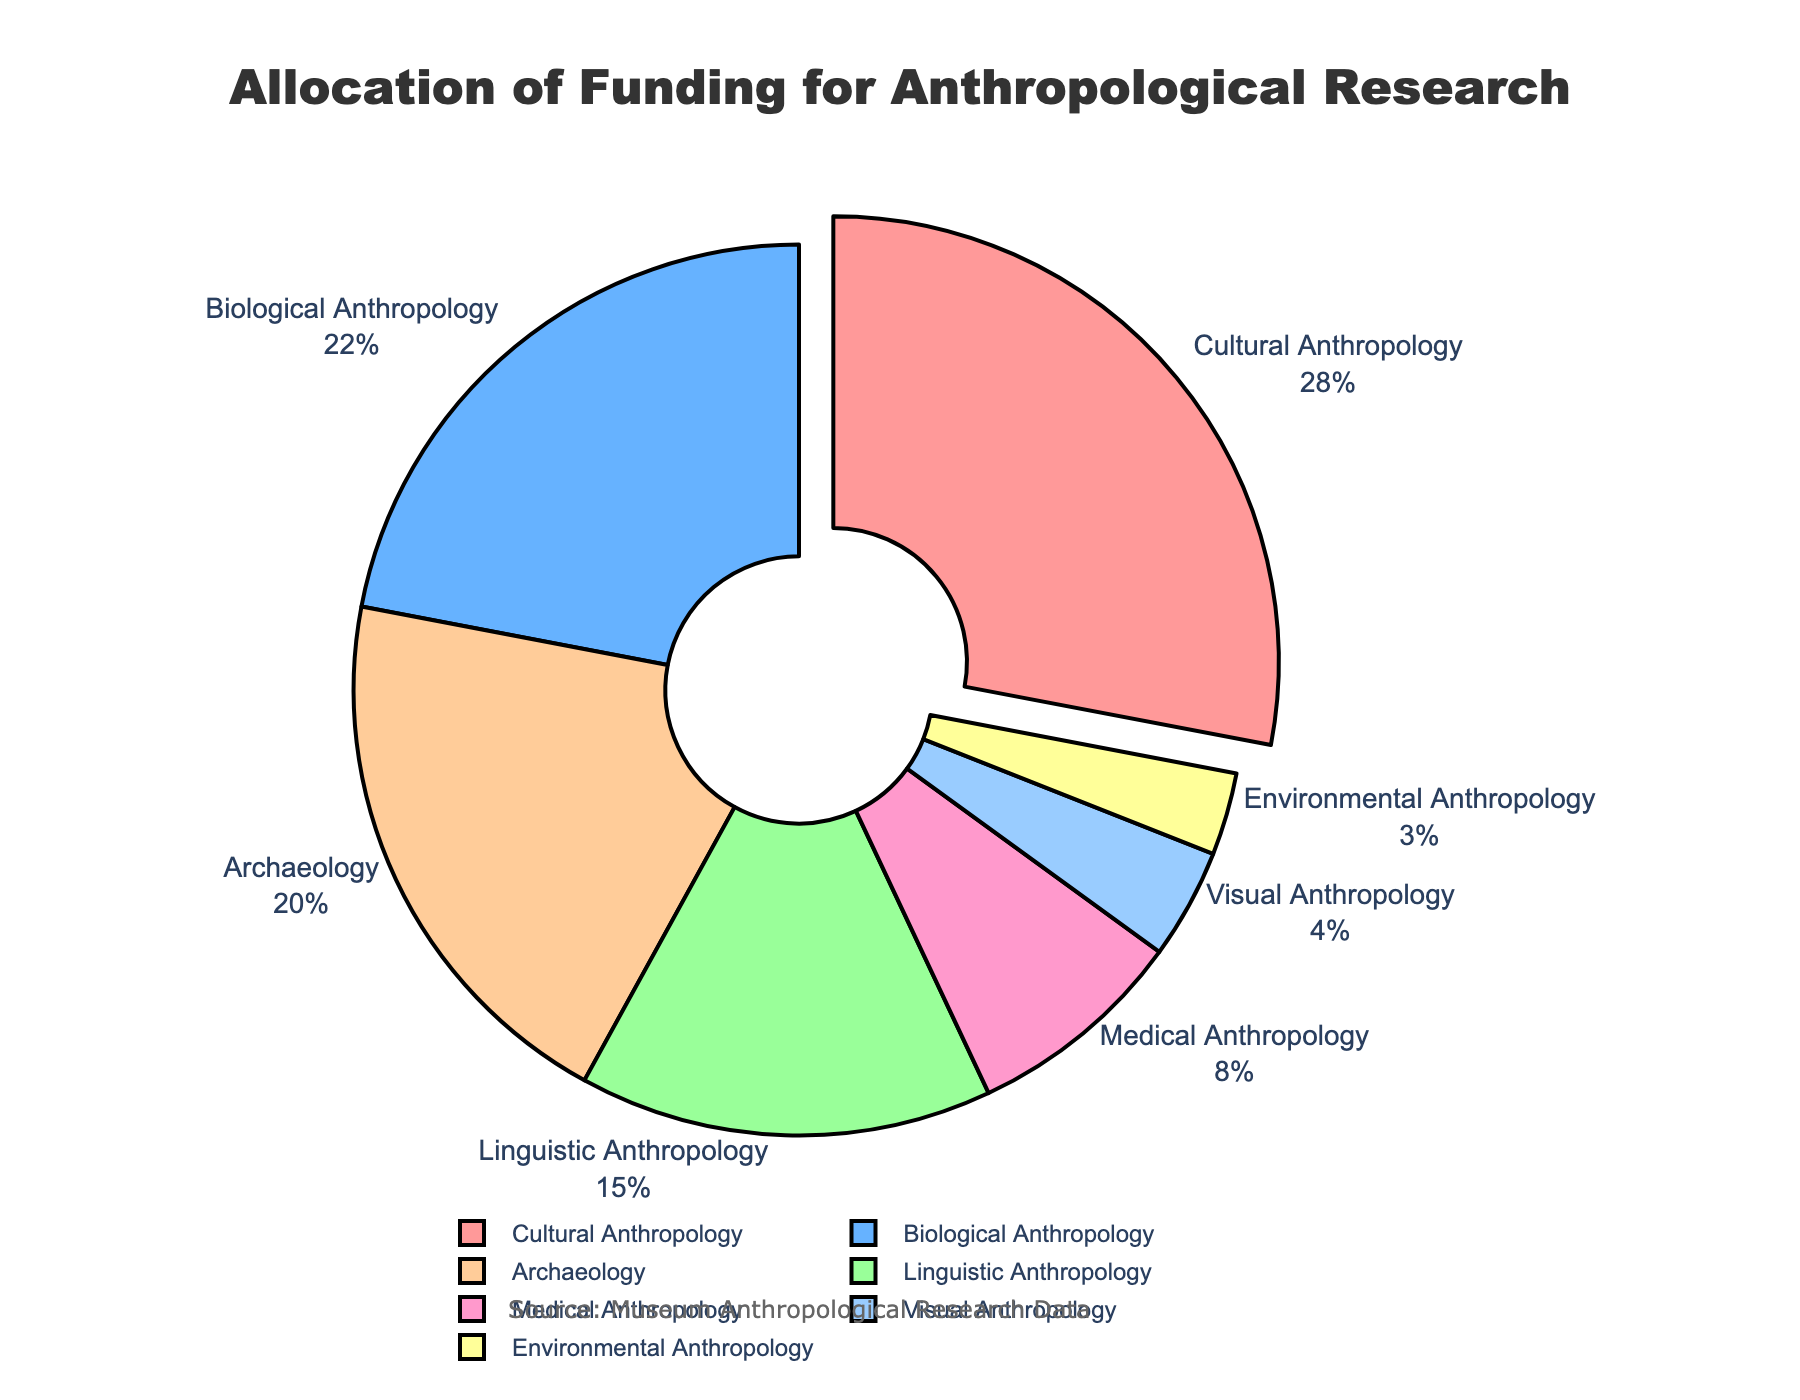Which research area receives the highest allocation of funding? The slice of the pie chart that stands out due to being slightly pulled away indicates the section with the highest allocation. It's labeled "Cultural Anthropology" receiving the highest allocation of 28%.
Answer: Cultural Anthropology Which research area receives the least allocation of funding? By examining the smallest slice in the pie chart, you can identify that "Environmental Anthropology" has the least allocation with 3%.
Answer: Environmental Anthropology How much more funding does Cultural Anthropology receive compared to Visual Anthropology? "Cultural Anthropology" receives 28% and "Visual Anthropology" receives 4%. The difference is calculated as 28% - 4% = 24%.
Answer: 24% What is the combined funding allocation for Linguistic Anthropology and Archaeology? According to the pie chart, "Linguistic Anthropology" has 15% and "Archaeology" has 20%. Adding these together gives 15% + 20% = 35%.
Answer: 35% Is the funding allocation for Medical Anthropology greater than that for Environmental Anthropology? "Medical Anthropology" receives 8% while "Environmental Anthropology" receives 3%. Comparing 8% and 3% shows that Medical Anthropology receives more funding.
Answer: Yes Which research areas receive a funding allocation of less than 10%? The pie chart shows that "Medical Anthropology" has 8%, "Visual Anthropology" has 4%, and "Environmental Anthropology" has 3%, all of which are below 10%.
Answer: Medical Anthropology, Visual Anthropology, Environmental Anthropology What is the total funding allocation for Biological Anthropology, Archaeology, and Linguistic Anthropology combined? Adding the allocations from the chart: "Biological Anthropology" is 22%, "Archaeology" is 20%, and "Linguistic Anthropology" is 15%. Thus, 22% + 20% + 15% = 57%.
Answer: 57% Is the funding allocation for Archaeology more than twice the funding allocation for Visual Anthropology? "Archaeology" receives 20% and "Visual Anthropology" receives 4%. Doubling the Visual Anthropology allocation is 4% * 2 = 8%. Since 20% is greater than 8%, the answer is yes.
Answer: Yes What percentage of funding is allocated to research areas other than Cultural Anthropology? "Cultural Anthropology" receives 28%, therefore the remaining is 100% - 28% = 72%.
Answer: 72% 